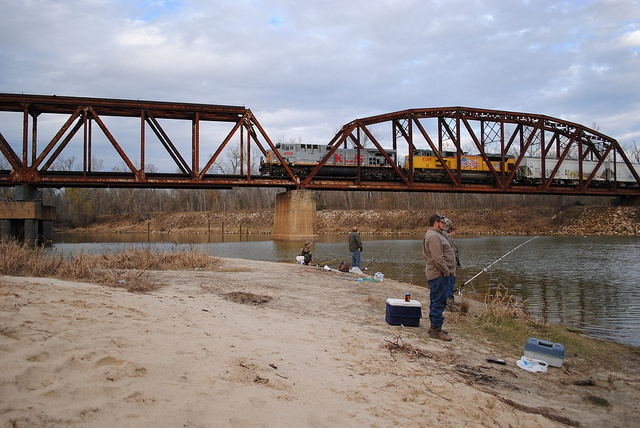Describe the objects in this image and their specific colors. I can see train in darkgray, black, gray, maroon, and olive tones, people in darkgray, black, gray, maroon, and navy tones, people in darkgray, gray, black, and navy tones, people in darkgray, black, gray, and darkblue tones, and people in darkgray, black, gray, and maroon tones in this image. 